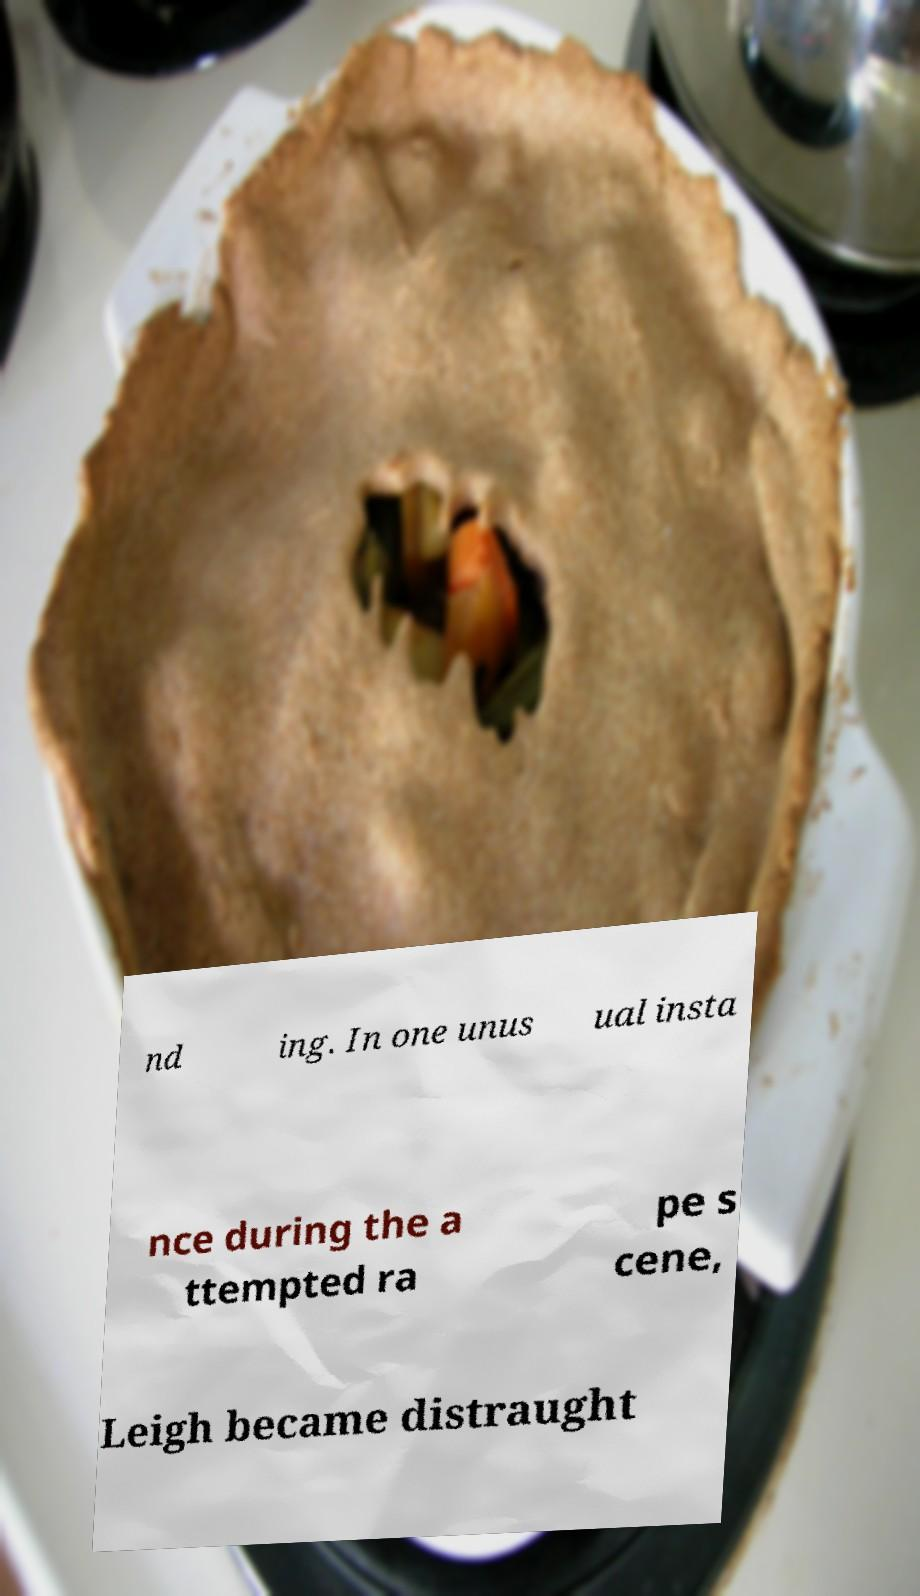Could you assist in decoding the text presented in this image and type it out clearly? nd ing. In one unus ual insta nce during the a ttempted ra pe s cene, Leigh became distraught 